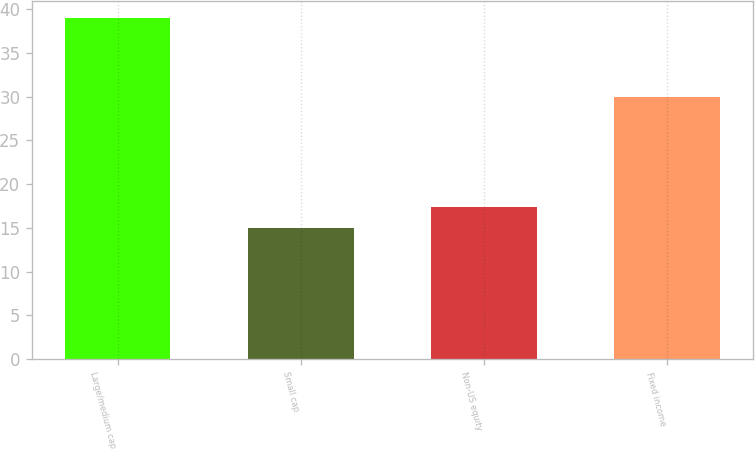Convert chart to OTSL. <chart><loc_0><loc_0><loc_500><loc_500><bar_chart><fcel>Large/medium cap<fcel>Small cap<fcel>Non-US equity<fcel>Fixed income<nl><fcel>39<fcel>15<fcel>17.4<fcel>30<nl></chart> 